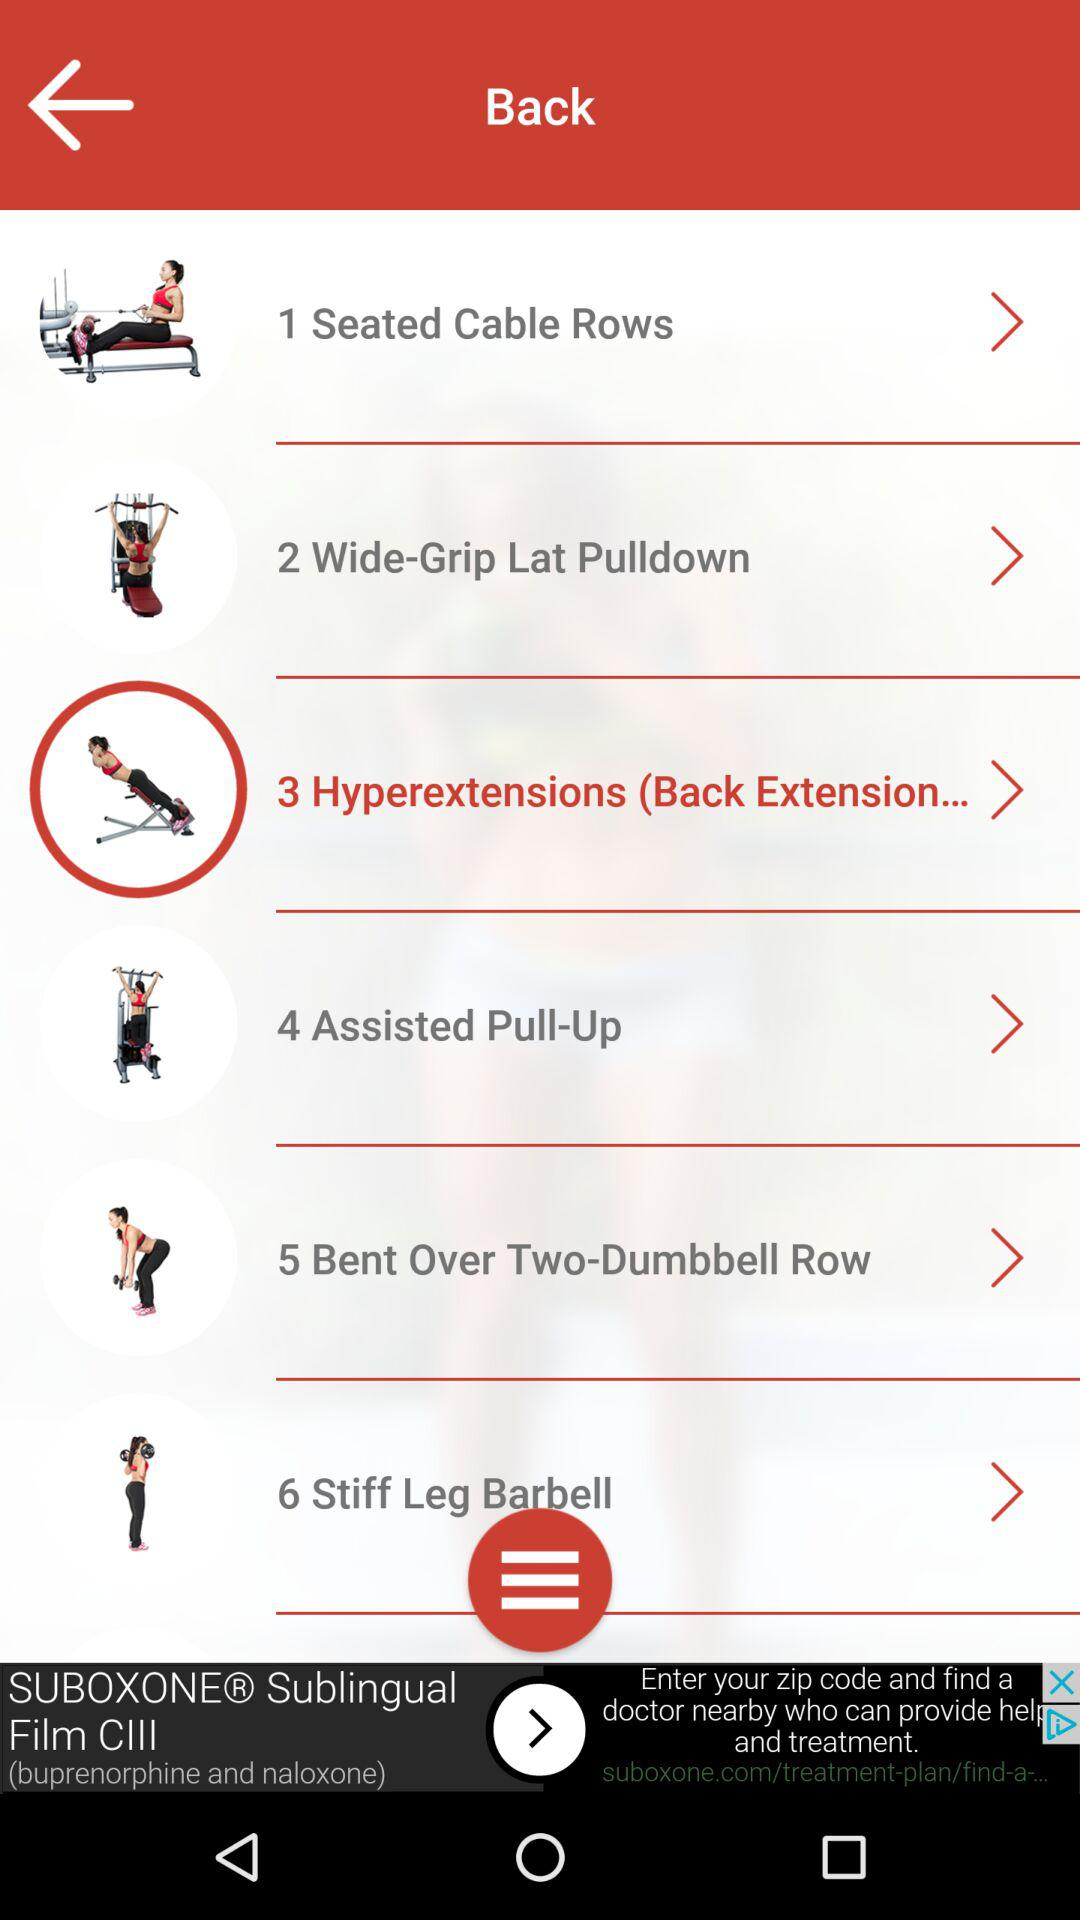How many exercises are there in total?
Answer the question using a single word or phrase. 6 